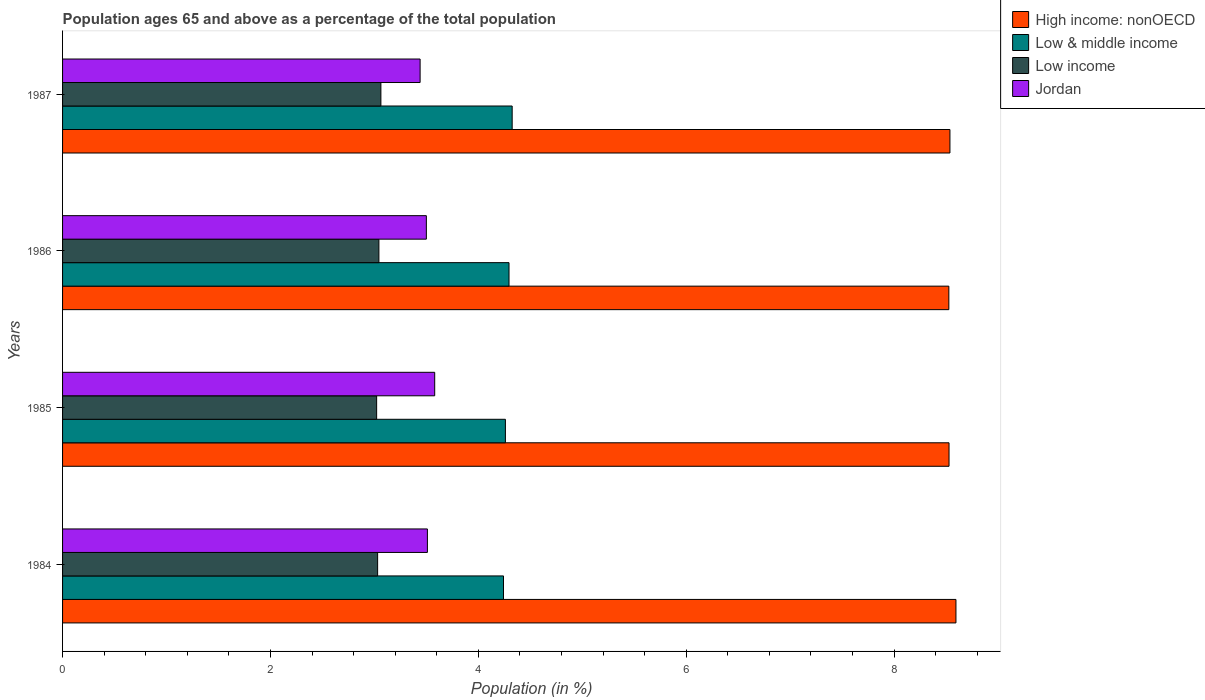How many bars are there on the 2nd tick from the top?
Give a very brief answer. 4. How many bars are there on the 4th tick from the bottom?
Keep it short and to the point. 4. What is the percentage of the population ages 65 and above in Low income in 1984?
Give a very brief answer. 3.03. Across all years, what is the maximum percentage of the population ages 65 and above in Low & middle income?
Your answer should be very brief. 4.33. Across all years, what is the minimum percentage of the population ages 65 and above in High income: nonOECD?
Provide a succinct answer. 8.53. In which year was the percentage of the population ages 65 and above in Jordan maximum?
Offer a very short reply. 1985. In which year was the percentage of the population ages 65 and above in Jordan minimum?
Provide a succinct answer. 1987. What is the total percentage of the population ages 65 and above in Jordan in the graph?
Your response must be concise. 14.03. What is the difference between the percentage of the population ages 65 and above in Jordan in 1985 and that in 1986?
Give a very brief answer. 0.08. What is the difference between the percentage of the population ages 65 and above in Jordan in 1984 and the percentage of the population ages 65 and above in Low income in 1986?
Provide a succinct answer. 0.47. What is the average percentage of the population ages 65 and above in Jordan per year?
Offer a very short reply. 3.51. In the year 1985, what is the difference between the percentage of the population ages 65 and above in Jordan and percentage of the population ages 65 and above in Low income?
Offer a very short reply. 0.56. What is the ratio of the percentage of the population ages 65 and above in High income: nonOECD in 1985 to that in 1987?
Make the answer very short. 1. Is the difference between the percentage of the population ages 65 and above in Jordan in 1985 and 1986 greater than the difference between the percentage of the population ages 65 and above in Low income in 1985 and 1986?
Provide a short and direct response. Yes. What is the difference between the highest and the second highest percentage of the population ages 65 and above in Low & middle income?
Give a very brief answer. 0.03. What is the difference between the highest and the lowest percentage of the population ages 65 and above in Jordan?
Make the answer very short. 0.14. In how many years, is the percentage of the population ages 65 and above in Jordan greater than the average percentage of the population ages 65 and above in Jordan taken over all years?
Your response must be concise. 2. Is the sum of the percentage of the population ages 65 and above in Low income in 1984 and 1987 greater than the maximum percentage of the population ages 65 and above in Low & middle income across all years?
Provide a succinct answer. Yes. What does the 2nd bar from the top in 1985 represents?
Make the answer very short. Low income. What does the 2nd bar from the bottom in 1984 represents?
Your answer should be very brief. Low & middle income. How many bars are there?
Offer a very short reply. 16. Are all the bars in the graph horizontal?
Provide a short and direct response. Yes. How many years are there in the graph?
Provide a succinct answer. 4. Are the values on the major ticks of X-axis written in scientific E-notation?
Your answer should be very brief. No. Does the graph contain any zero values?
Your response must be concise. No. Does the graph contain grids?
Offer a very short reply. No. Where does the legend appear in the graph?
Provide a short and direct response. Top right. How many legend labels are there?
Keep it short and to the point. 4. What is the title of the graph?
Provide a succinct answer. Population ages 65 and above as a percentage of the total population. What is the label or title of the Y-axis?
Keep it short and to the point. Years. What is the Population (in %) in High income: nonOECD in 1984?
Make the answer very short. 8.6. What is the Population (in %) of Low & middle income in 1984?
Give a very brief answer. 4.24. What is the Population (in %) in Low income in 1984?
Provide a succinct answer. 3.03. What is the Population (in %) in Jordan in 1984?
Keep it short and to the point. 3.51. What is the Population (in %) in High income: nonOECD in 1985?
Offer a terse response. 8.53. What is the Population (in %) of Low & middle income in 1985?
Make the answer very short. 4.26. What is the Population (in %) in Low income in 1985?
Provide a succinct answer. 3.02. What is the Population (in %) in Jordan in 1985?
Your answer should be compact. 3.58. What is the Population (in %) in High income: nonOECD in 1986?
Offer a terse response. 8.53. What is the Population (in %) in Low & middle income in 1986?
Ensure brevity in your answer.  4.3. What is the Population (in %) in Low income in 1986?
Your answer should be compact. 3.04. What is the Population (in %) in Jordan in 1986?
Provide a succinct answer. 3.5. What is the Population (in %) in High income: nonOECD in 1987?
Give a very brief answer. 8.54. What is the Population (in %) in Low & middle income in 1987?
Make the answer very short. 4.33. What is the Population (in %) of Low income in 1987?
Make the answer very short. 3.06. What is the Population (in %) of Jordan in 1987?
Offer a terse response. 3.44. Across all years, what is the maximum Population (in %) of High income: nonOECD?
Make the answer very short. 8.6. Across all years, what is the maximum Population (in %) in Low & middle income?
Make the answer very short. 4.33. Across all years, what is the maximum Population (in %) in Low income?
Provide a short and direct response. 3.06. Across all years, what is the maximum Population (in %) of Jordan?
Give a very brief answer. 3.58. Across all years, what is the minimum Population (in %) in High income: nonOECD?
Keep it short and to the point. 8.53. Across all years, what is the minimum Population (in %) of Low & middle income?
Make the answer very short. 4.24. Across all years, what is the minimum Population (in %) of Low income?
Your answer should be compact. 3.02. Across all years, what is the minimum Population (in %) of Jordan?
Offer a very short reply. 3.44. What is the total Population (in %) in High income: nonOECD in the graph?
Make the answer very short. 34.19. What is the total Population (in %) in Low & middle income in the graph?
Your answer should be very brief. 17.12. What is the total Population (in %) of Low income in the graph?
Make the answer very short. 12.16. What is the total Population (in %) in Jordan in the graph?
Make the answer very short. 14.03. What is the difference between the Population (in %) of High income: nonOECD in 1984 and that in 1985?
Provide a succinct answer. 0.07. What is the difference between the Population (in %) of Low & middle income in 1984 and that in 1985?
Offer a terse response. -0.02. What is the difference between the Population (in %) of Low income in 1984 and that in 1985?
Your answer should be compact. 0.01. What is the difference between the Population (in %) in Jordan in 1984 and that in 1985?
Provide a succinct answer. -0.07. What is the difference between the Population (in %) in High income: nonOECD in 1984 and that in 1986?
Make the answer very short. 0.07. What is the difference between the Population (in %) of Low & middle income in 1984 and that in 1986?
Make the answer very short. -0.05. What is the difference between the Population (in %) of Low income in 1984 and that in 1986?
Offer a very short reply. -0.01. What is the difference between the Population (in %) of Jordan in 1984 and that in 1986?
Ensure brevity in your answer.  0.01. What is the difference between the Population (in %) of High income: nonOECD in 1984 and that in 1987?
Offer a very short reply. 0.06. What is the difference between the Population (in %) of Low & middle income in 1984 and that in 1987?
Your answer should be very brief. -0.08. What is the difference between the Population (in %) in Low income in 1984 and that in 1987?
Give a very brief answer. -0.03. What is the difference between the Population (in %) of Jordan in 1984 and that in 1987?
Make the answer very short. 0.07. What is the difference between the Population (in %) in High income: nonOECD in 1985 and that in 1986?
Your answer should be very brief. 0. What is the difference between the Population (in %) of Low & middle income in 1985 and that in 1986?
Offer a terse response. -0.03. What is the difference between the Population (in %) of Low income in 1985 and that in 1986?
Provide a succinct answer. -0.02. What is the difference between the Population (in %) in Jordan in 1985 and that in 1986?
Ensure brevity in your answer.  0.08. What is the difference between the Population (in %) of High income: nonOECD in 1985 and that in 1987?
Make the answer very short. -0.01. What is the difference between the Population (in %) in Low & middle income in 1985 and that in 1987?
Provide a succinct answer. -0.07. What is the difference between the Population (in %) of Low income in 1985 and that in 1987?
Ensure brevity in your answer.  -0.04. What is the difference between the Population (in %) of Jordan in 1985 and that in 1987?
Your answer should be compact. 0.14. What is the difference between the Population (in %) in High income: nonOECD in 1986 and that in 1987?
Ensure brevity in your answer.  -0.01. What is the difference between the Population (in %) in Low & middle income in 1986 and that in 1987?
Your response must be concise. -0.03. What is the difference between the Population (in %) of Low income in 1986 and that in 1987?
Make the answer very short. -0.02. What is the difference between the Population (in %) of Jordan in 1986 and that in 1987?
Your answer should be very brief. 0.06. What is the difference between the Population (in %) in High income: nonOECD in 1984 and the Population (in %) in Low & middle income in 1985?
Make the answer very short. 4.33. What is the difference between the Population (in %) of High income: nonOECD in 1984 and the Population (in %) of Low income in 1985?
Provide a succinct answer. 5.57. What is the difference between the Population (in %) of High income: nonOECD in 1984 and the Population (in %) of Jordan in 1985?
Make the answer very short. 5.01. What is the difference between the Population (in %) of Low & middle income in 1984 and the Population (in %) of Low income in 1985?
Make the answer very short. 1.22. What is the difference between the Population (in %) in Low & middle income in 1984 and the Population (in %) in Jordan in 1985?
Offer a terse response. 0.66. What is the difference between the Population (in %) in Low income in 1984 and the Population (in %) in Jordan in 1985?
Offer a very short reply. -0.55. What is the difference between the Population (in %) in High income: nonOECD in 1984 and the Population (in %) in Low & middle income in 1986?
Your answer should be very brief. 4.3. What is the difference between the Population (in %) in High income: nonOECD in 1984 and the Population (in %) in Low income in 1986?
Your answer should be very brief. 5.55. What is the difference between the Population (in %) in High income: nonOECD in 1984 and the Population (in %) in Jordan in 1986?
Provide a succinct answer. 5.1. What is the difference between the Population (in %) in Low & middle income in 1984 and the Population (in %) in Low income in 1986?
Give a very brief answer. 1.2. What is the difference between the Population (in %) in Low & middle income in 1984 and the Population (in %) in Jordan in 1986?
Provide a short and direct response. 0.74. What is the difference between the Population (in %) of Low income in 1984 and the Population (in %) of Jordan in 1986?
Your answer should be very brief. -0.47. What is the difference between the Population (in %) in High income: nonOECD in 1984 and the Population (in %) in Low & middle income in 1987?
Offer a very short reply. 4.27. What is the difference between the Population (in %) of High income: nonOECD in 1984 and the Population (in %) of Low income in 1987?
Keep it short and to the point. 5.53. What is the difference between the Population (in %) of High income: nonOECD in 1984 and the Population (in %) of Jordan in 1987?
Provide a succinct answer. 5.16. What is the difference between the Population (in %) in Low & middle income in 1984 and the Population (in %) in Low income in 1987?
Give a very brief answer. 1.18. What is the difference between the Population (in %) of Low & middle income in 1984 and the Population (in %) of Jordan in 1987?
Ensure brevity in your answer.  0.8. What is the difference between the Population (in %) of Low income in 1984 and the Population (in %) of Jordan in 1987?
Keep it short and to the point. -0.41. What is the difference between the Population (in %) of High income: nonOECD in 1985 and the Population (in %) of Low & middle income in 1986?
Provide a short and direct response. 4.23. What is the difference between the Population (in %) in High income: nonOECD in 1985 and the Population (in %) in Low income in 1986?
Provide a succinct answer. 5.49. What is the difference between the Population (in %) of High income: nonOECD in 1985 and the Population (in %) of Jordan in 1986?
Ensure brevity in your answer.  5.03. What is the difference between the Population (in %) in Low & middle income in 1985 and the Population (in %) in Low income in 1986?
Your answer should be very brief. 1.22. What is the difference between the Population (in %) in Low & middle income in 1985 and the Population (in %) in Jordan in 1986?
Offer a terse response. 0.76. What is the difference between the Population (in %) of Low income in 1985 and the Population (in %) of Jordan in 1986?
Ensure brevity in your answer.  -0.48. What is the difference between the Population (in %) of High income: nonOECD in 1985 and the Population (in %) of Low & middle income in 1987?
Ensure brevity in your answer.  4.2. What is the difference between the Population (in %) of High income: nonOECD in 1985 and the Population (in %) of Low income in 1987?
Keep it short and to the point. 5.47. What is the difference between the Population (in %) in High income: nonOECD in 1985 and the Population (in %) in Jordan in 1987?
Your response must be concise. 5.09. What is the difference between the Population (in %) of Low & middle income in 1985 and the Population (in %) of Low income in 1987?
Offer a terse response. 1.2. What is the difference between the Population (in %) of Low & middle income in 1985 and the Population (in %) of Jordan in 1987?
Provide a succinct answer. 0.82. What is the difference between the Population (in %) of Low income in 1985 and the Population (in %) of Jordan in 1987?
Make the answer very short. -0.42. What is the difference between the Population (in %) in High income: nonOECD in 1986 and the Population (in %) in Low & middle income in 1987?
Provide a short and direct response. 4.2. What is the difference between the Population (in %) of High income: nonOECD in 1986 and the Population (in %) of Low income in 1987?
Ensure brevity in your answer.  5.46. What is the difference between the Population (in %) of High income: nonOECD in 1986 and the Population (in %) of Jordan in 1987?
Offer a terse response. 5.09. What is the difference between the Population (in %) in Low & middle income in 1986 and the Population (in %) in Low income in 1987?
Give a very brief answer. 1.23. What is the difference between the Population (in %) in Low & middle income in 1986 and the Population (in %) in Jordan in 1987?
Make the answer very short. 0.86. What is the difference between the Population (in %) in Low income in 1986 and the Population (in %) in Jordan in 1987?
Your answer should be compact. -0.4. What is the average Population (in %) in High income: nonOECD per year?
Offer a terse response. 8.55. What is the average Population (in %) in Low & middle income per year?
Your answer should be very brief. 4.28. What is the average Population (in %) in Low income per year?
Keep it short and to the point. 3.04. What is the average Population (in %) of Jordan per year?
Make the answer very short. 3.51. In the year 1984, what is the difference between the Population (in %) in High income: nonOECD and Population (in %) in Low & middle income?
Provide a succinct answer. 4.35. In the year 1984, what is the difference between the Population (in %) of High income: nonOECD and Population (in %) of Low income?
Make the answer very short. 5.56. In the year 1984, what is the difference between the Population (in %) in High income: nonOECD and Population (in %) in Jordan?
Give a very brief answer. 5.09. In the year 1984, what is the difference between the Population (in %) of Low & middle income and Population (in %) of Low income?
Give a very brief answer. 1.21. In the year 1984, what is the difference between the Population (in %) in Low & middle income and Population (in %) in Jordan?
Your response must be concise. 0.73. In the year 1984, what is the difference between the Population (in %) of Low income and Population (in %) of Jordan?
Your answer should be compact. -0.48. In the year 1985, what is the difference between the Population (in %) in High income: nonOECD and Population (in %) in Low & middle income?
Provide a succinct answer. 4.27. In the year 1985, what is the difference between the Population (in %) in High income: nonOECD and Population (in %) in Low income?
Your response must be concise. 5.51. In the year 1985, what is the difference between the Population (in %) in High income: nonOECD and Population (in %) in Jordan?
Offer a terse response. 4.95. In the year 1985, what is the difference between the Population (in %) of Low & middle income and Population (in %) of Low income?
Offer a terse response. 1.24. In the year 1985, what is the difference between the Population (in %) of Low & middle income and Population (in %) of Jordan?
Offer a terse response. 0.68. In the year 1985, what is the difference between the Population (in %) in Low income and Population (in %) in Jordan?
Ensure brevity in your answer.  -0.56. In the year 1986, what is the difference between the Population (in %) in High income: nonOECD and Population (in %) in Low & middle income?
Your response must be concise. 4.23. In the year 1986, what is the difference between the Population (in %) of High income: nonOECD and Population (in %) of Low income?
Your answer should be very brief. 5.48. In the year 1986, what is the difference between the Population (in %) in High income: nonOECD and Population (in %) in Jordan?
Your answer should be very brief. 5.03. In the year 1986, what is the difference between the Population (in %) in Low & middle income and Population (in %) in Low income?
Your answer should be compact. 1.25. In the year 1986, what is the difference between the Population (in %) of Low & middle income and Population (in %) of Jordan?
Offer a terse response. 0.8. In the year 1986, what is the difference between the Population (in %) of Low income and Population (in %) of Jordan?
Make the answer very short. -0.46. In the year 1987, what is the difference between the Population (in %) of High income: nonOECD and Population (in %) of Low & middle income?
Offer a very short reply. 4.21. In the year 1987, what is the difference between the Population (in %) of High income: nonOECD and Population (in %) of Low income?
Make the answer very short. 5.47. In the year 1987, what is the difference between the Population (in %) of High income: nonOECD and Population (in %) of Jordan?
Your answer should be very brief. 5.1. In the year 1987, what is the difference between the Population (in %) in Low & middle income and Population (in %) in Low income?
Provide a short and direct response. 1.26. In the year 1987, what is the difference between the Population (in %) of Low & middle income and Population (in %) of Jordan?
Your answer should be compact. 0.89. In the year 1987, what is the difference between the Population (in %) of Low income and Population (in %) of Jordan?
Provide a short and direct response. -0.38. What is the ratio of the Population (in %) of High income: nonOECD in 1984 to that in 1985?
Your answer should be compact. 1.01. What is the ratio of the Population (in %) in Low & middle income in 1984 to that in 1985?
Offer a terse response. 1. What is the ratio of the Population (in %) of Jordan in 1984 to that in 1985?
Provide a succinct answer. 0.98. What is the ratio of the Population (in %) in High income: nonOECD in 1984 to that in 1986?
Your answer should be compact. 1.01. What is the ratio of the Population (in %) in Low & middle income in 1984 to that in 1986?
Offer a terse response. 0.99. What is the ratio of the Population (in %) in Low income in 1984 to that in 1986?
Your response must be concise. 1. What is the ratio of the Population (in %) of Jordan in 1984 to that in 1986?
Your answer should be very brief. 1. What is the ratio of the Population (in %) in High income: nonOECD in 1984 to that in 1987?
Give a very brief answer. 1.01. What is the ratio of the Population (in %) of Low & middle income in 1984 to that in 1987?
Offer a terse response. 0.98. What is the ratio of the Population (in %) of Low income in 1984 to that in 1987?
Your answer should be compact. 0.99. What is the ratio of the Population (in %) in Jordan in 1984 to that in 1987?
Provide a succinct answer. 1.02. What is the ratio of the Population (in %) of Low & middle income in 1985 to that in 1986?
Your response must be concise. 0.99. What is the ratio of the Population (in %) of Low income in 1985 to that in 1986?
Give a very brief answer. 0.99. What is the ratio of the Population (in %) in Jordan in 1985 to that in 1986?
Offer a terse response. 1.02. What is the ratio of the Population (in %) in High income: nonOECD in 1985 to that in 1987?
Keep it short and to the point. 1. What is the ratio of the Population (in %) of Low income in 1985 to that in 1987?
Ensure brevity in your answer.  0.99. What is the ratio of the Population (in %) of Jordan in 1985 to that in 1987?
Make the answer very short. 1.04. What is the ratio of the Population (in %) of Low & middle income in 1986 to that in 1987?
Your response must be concise. 0.99. What is the ratio of the Population (in %) of Low income in 1986 to that in 1987?
Your response must be concise. 0.99. What is the ratio of the Population (in %) in Jordan in 1986 to that in 1987?
Your answer should be compact. 1.02. What is the difference between the highest and the second highest Population (in %) in High income: nonOECD?
Provide a short and direct response. 0.06. What is the difference between the highest and the second highest Population (in %) in Low & middle income?
Provide a short and direct response. 0.03. What is the difference between the highest and the second highest Population (in %) in Low income?
Make the answer very short. 0.02. What is the difference between the highest and the second highest Population (in %) of Jordan?
Provide a succinct answer. 0.07. What is the difference between the highest and the lowest Population (in %) in High income: nonOECD?
Keep it short and to the point. 0.07. What is the difference between the highest and the lowest Population (in %) in Low & middle income?
Give a very brief answer. 0.08. What is the difference between the highest and the lowest Population (in %) of Low income?
Your answer should be compact. 0.04. What is the difference between the highest and the lowest Population (in %) in Jordan?
Make the answer very short. 0.14. 